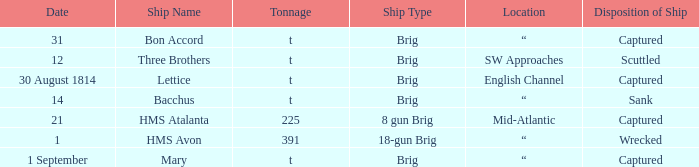With 14 under the date, what is the tonnage of the ship? T. 